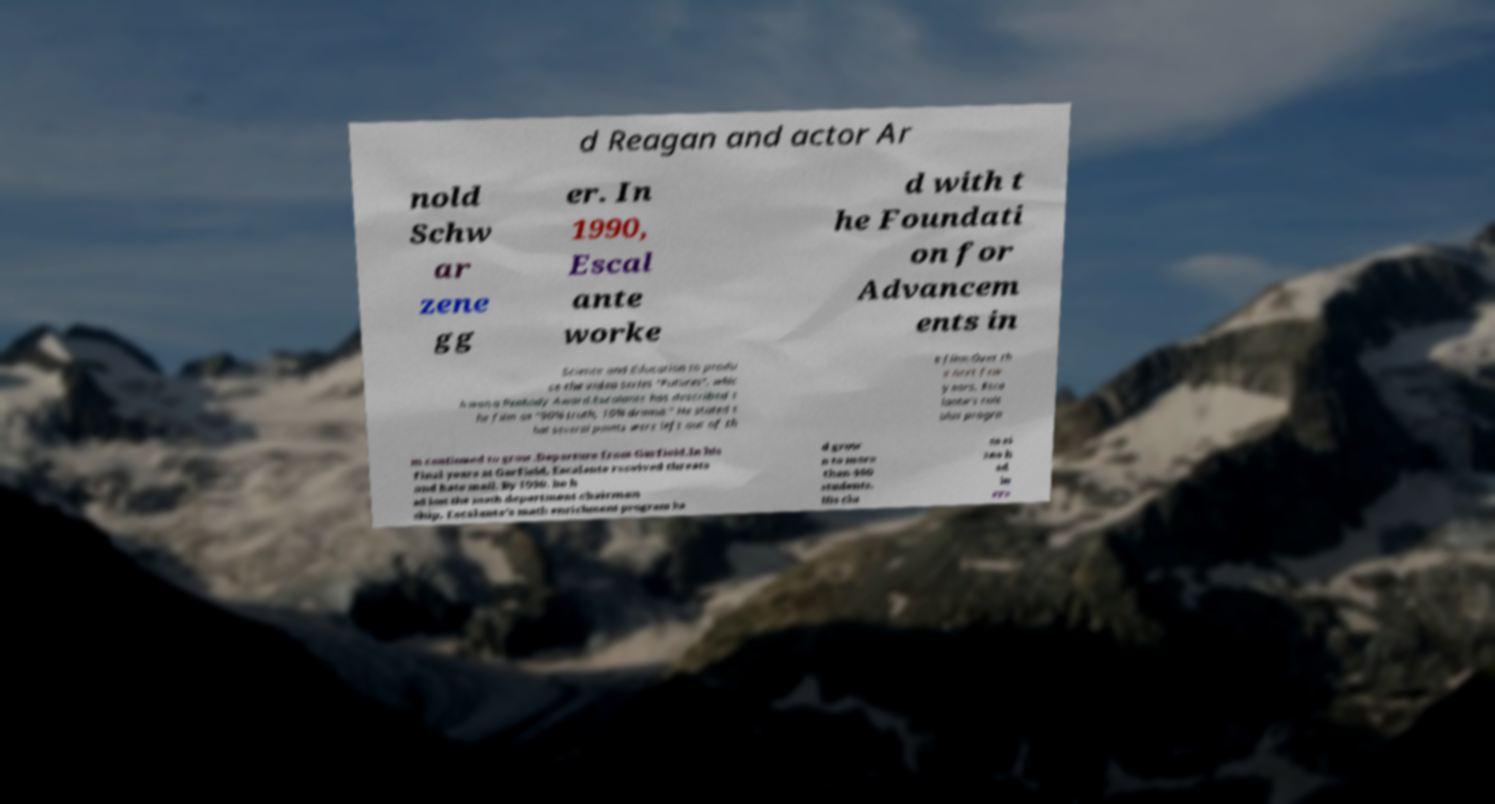Please read and relay the text visible in this image. What does it say? d Reagan and actor Ar nold Schw ar zene gg er. In 1990, Escal ante worke d with t he Foundati on for Advancem ents in Science and Education to produ ce the video series "Futures", whic h won a Peabody Award.Escalante has described t he film as "90% truth, 10% drama." He stated t hat several points were left out of th e film:Over th e next few years, Esca lante's calc ulus progra m continued to grow.Departure from Garfield.In his final years at Garfield, Escalante received threats and hate mail. By 1990, he h ad lost the math department chairman ship. Escalante's math enrichment program ha d grow n to more than 400 students. His cla ss si zes h ad in cre 